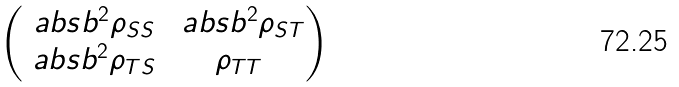Convert formula to latex. <formula><loc_0><loc_0><loc_500><loc_500>\begin{pmatrix} \ a b s { b } ^ { 2 } \rho _ { S S } & \ a b s { b } ^ { 2 } \rho _ { S T } \\ \ a b s { b } ^ { 2 } \rho _ { T S } & \rho _ { T T } \end{pmatrix}</formula> 